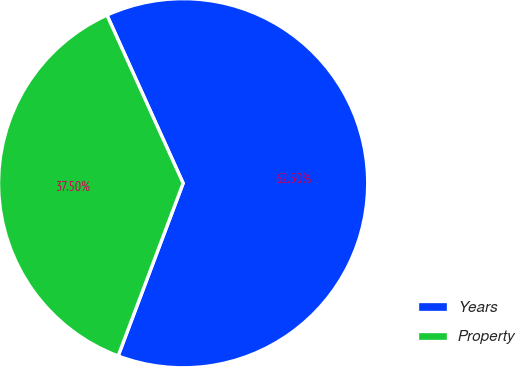Convert chart to OTSL. <chart><loc_0><loc_0><loc_500><loc_500><pie_chart><fcel>Years<fcel>Property<nl><fcel>62.5%<fcel>37.5%<nl></chart> 